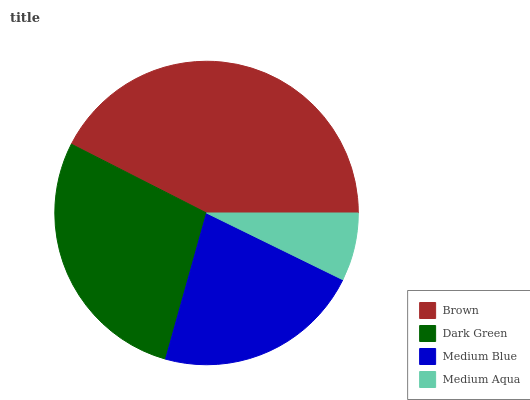Is Medium Aqua the minimum?
Answer yes or no. Yes. Is Brown the maximum?
Answer yes or no. Yes. Is Dark Green the minimum?
Answer yes or no. No. Is Dark Green the maximum?
Answer yes or no. No. Is Brown greater than Dark Green?
Answer yes or no. Yes. Is Dark Green less than Brown?
Answer yes or no. Yes. Is Dark Green greater than Brown?
Answer yes or no. No. Is Brown less than Dark Green?
Answer yes or no. No. Is Dark Green the high median?
Answer yes or no. Yes. Is Medium Blue the low median?
Answer yes or no. Yes. Is Medium Aqua the high median?
Answer yes or no. No. Is Brown the low median?
Answer yes or no. No. 